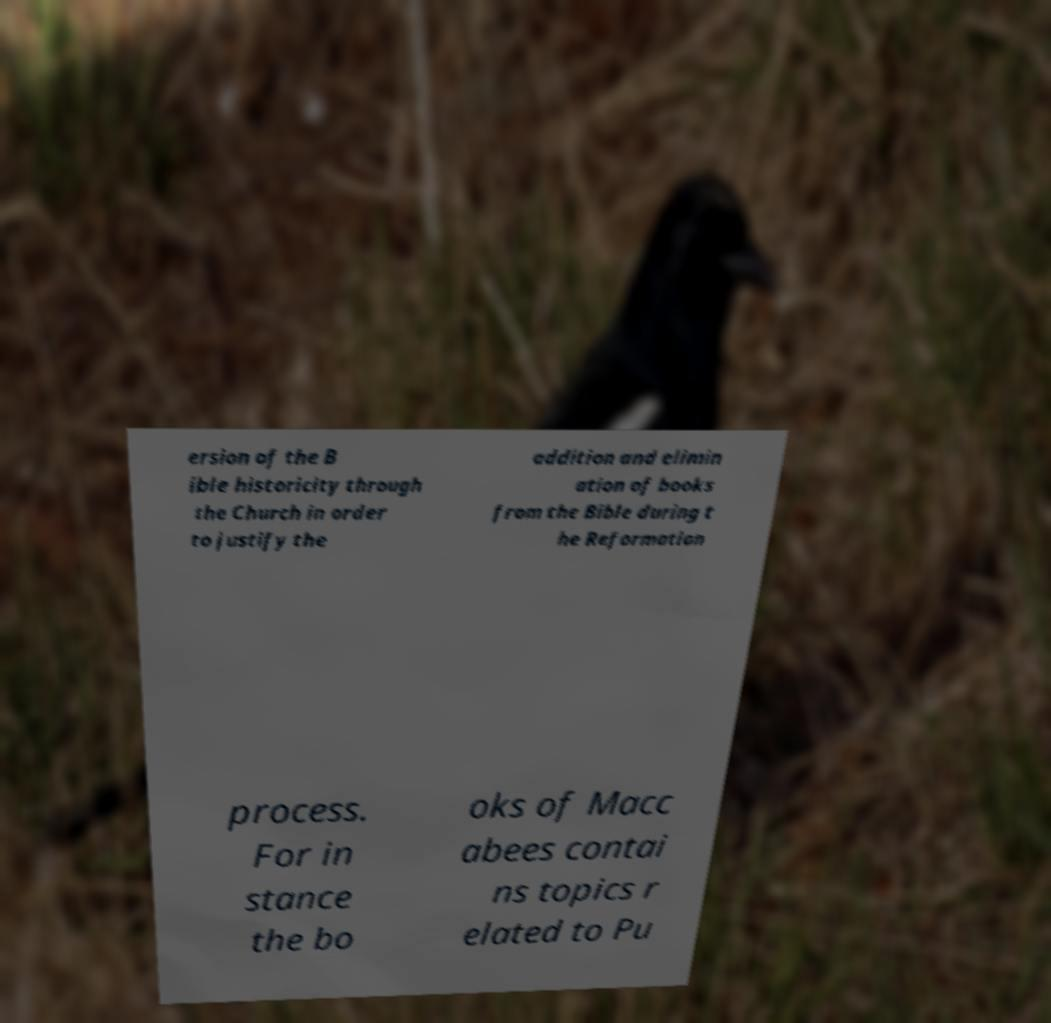I need the written content from this picture converted into text. Can you do that? ersion of the B ible historicity through the Church in order to justify the addition and elimin ation of books from the Bible during t he Reformation process. For in stance the bo oks of Macc abees contai ns topics r elated to Pu 